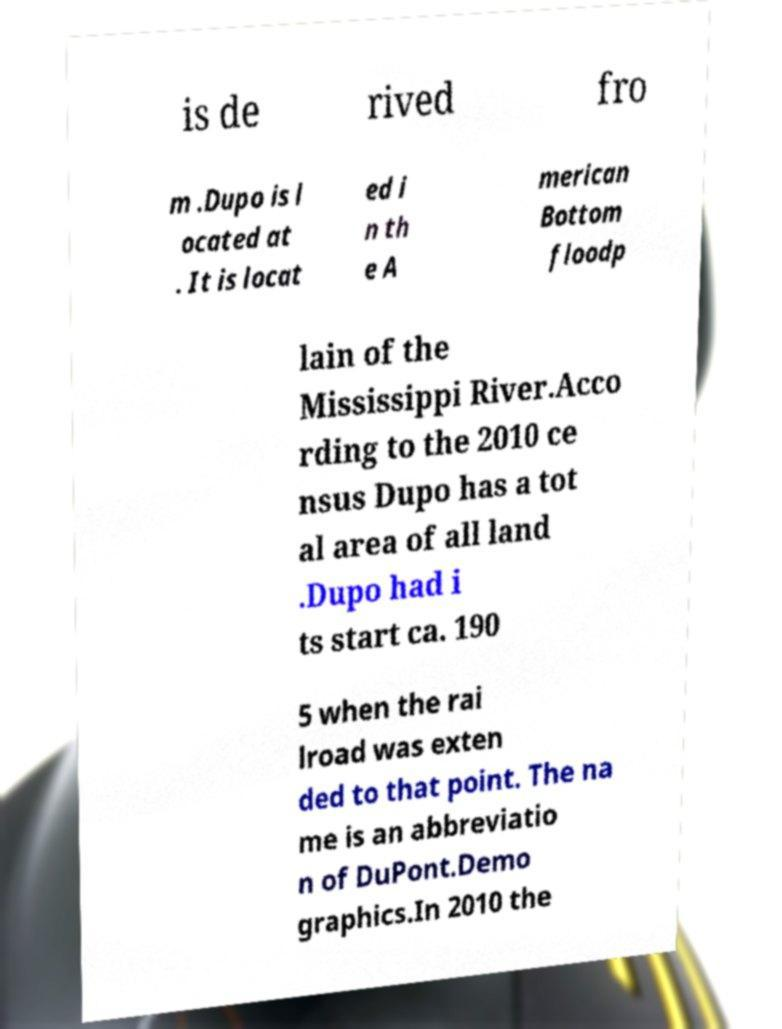Could you assist in decoding the text presented in this image and type it out clearly? is de rived fro m .Dupo is l ocated at . It is locat ed i n th e A merican Bottom floodp lain of the Mississippi River.Acco rding to the 2010 ce nsus Dupo has a tot al area of all land .Dupo had i ts start ca. 190 5 when the rai lroad was exten ded to that point. The na me is an abbreviatio n of DuPont.Demo graphics.In 2010 the 